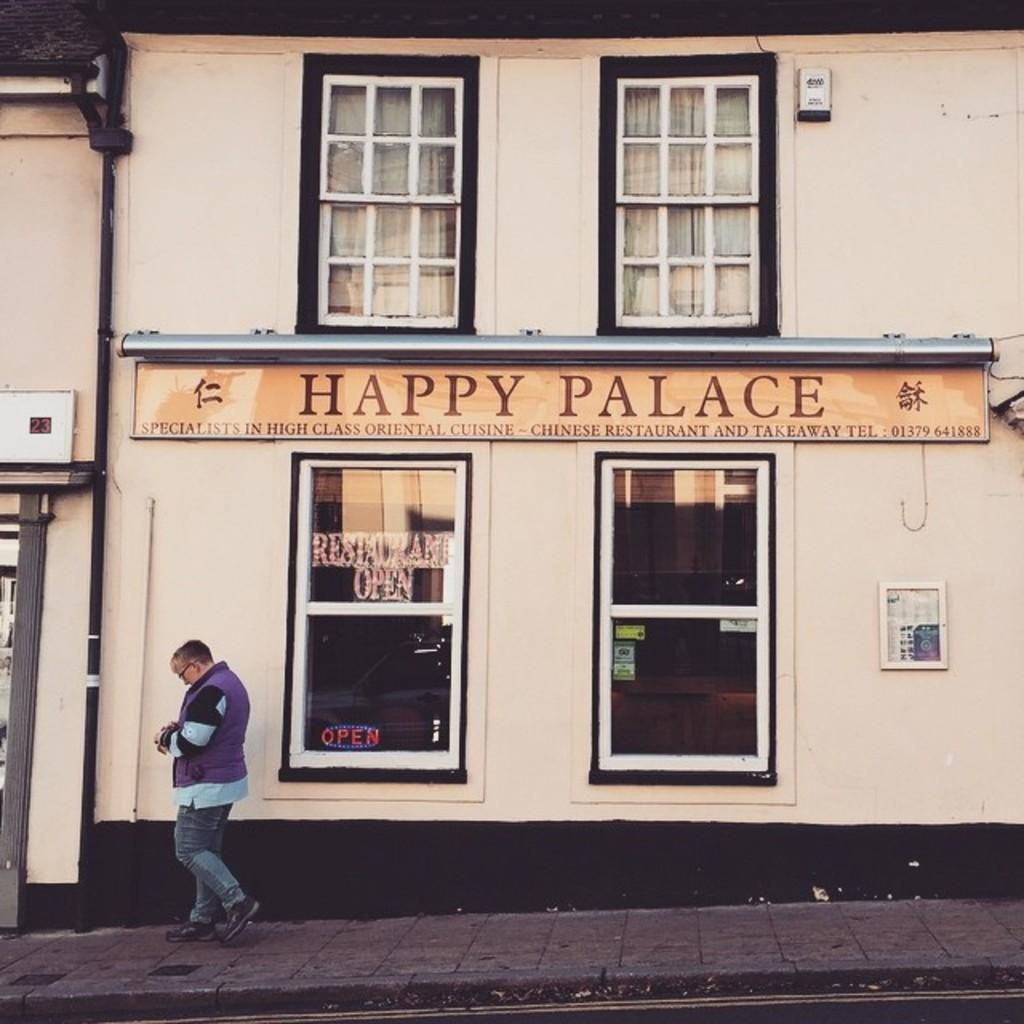What is the person in the image doing? The person is walking in the image. Where is the person walking? The person is walking on a footpath. What can be seen in the background of the image? There are windows, curtains, a name board, a pipe, and a wall in the background of the image. What type of powder is being used by the machine in the image? There is no machine or powder present in the image. What color is the pencil being used by the person in the image? There is no pencil visible in the image; the person is walking on a footpath. 